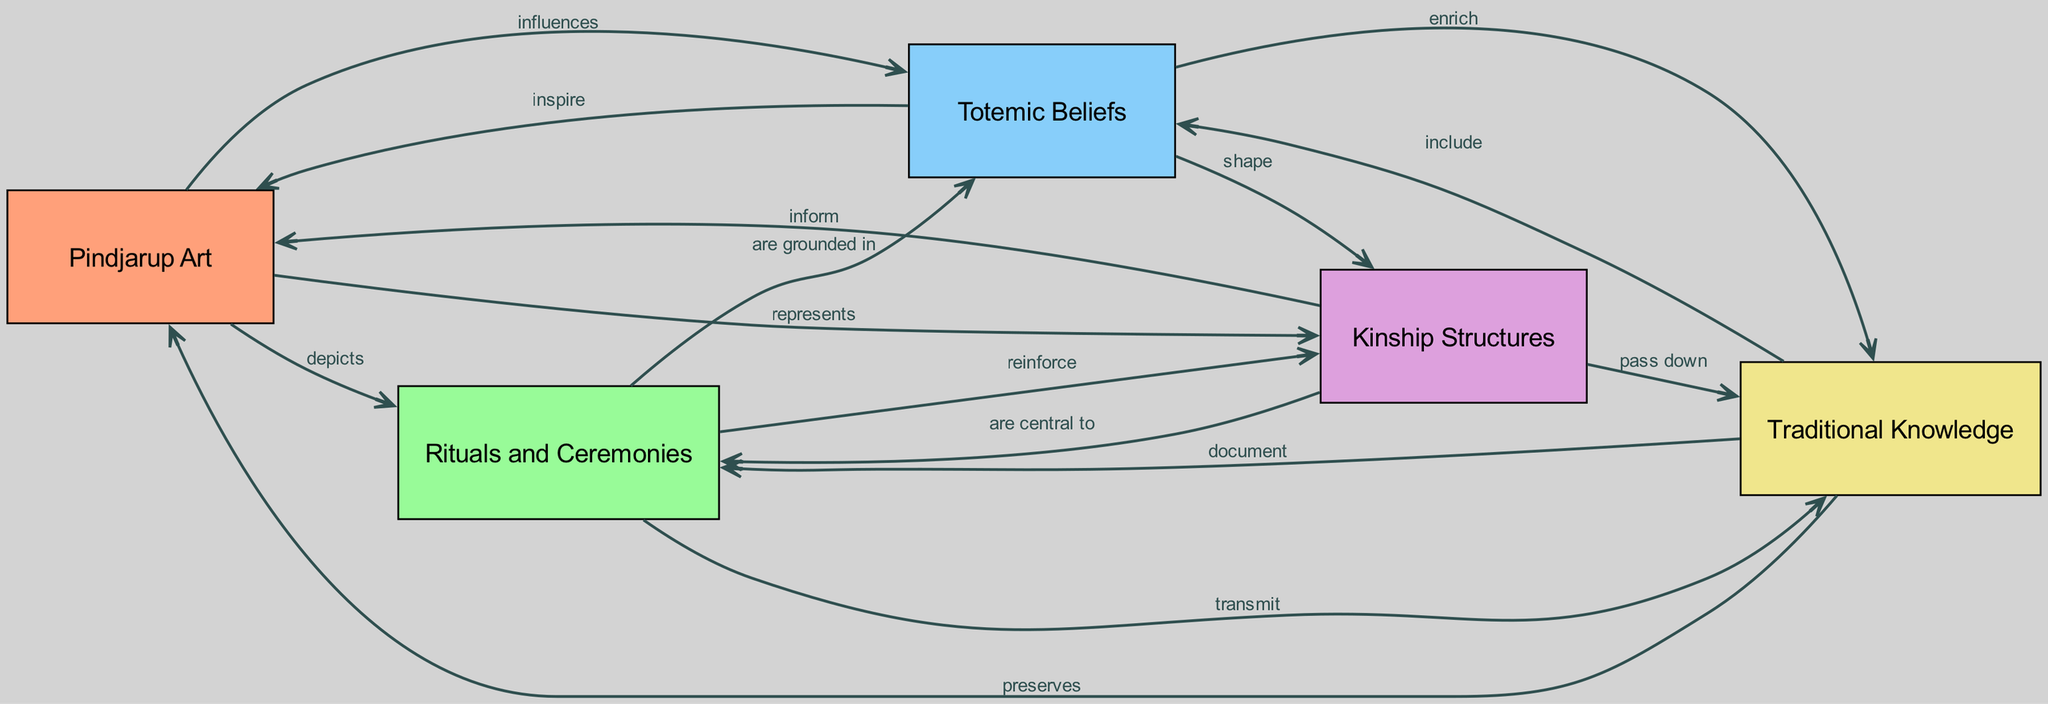What are the three main elements depicted in the diagram? The diagram includes Pindjarup Art, Rituals and Ceremonies, and Totemic Beliefs as the main elements. Each of these is represented as a separate node in the diagram, illustrating the interconnectedness of these cultural practices.
Answer: Pindjarup Art, Rituals and Ceremonies, Totemic Beliefs What type of relationship exists between Totemic Beliefs and Pindjarup Art? The relationship between Totemic Beliefs and Pindjarup Art is described as "inspire." This indicates that Totemic Beliefs creatively influence the expression of Pindjarup Art in the diagram.
Answer: inspire How many relationships does Kinship Structures have? Kinship Structures has three relationships depicted in the diagram, illustrating its connections and influences on other elements such as Traditional Knowledge, Rituals and Ceremonies, and Pindjarup Art.
Answer: 3 How do Rituals and Ceremonies relate to Traditional Knowledge? Rituals and Ceremonies "transmit" Traditional Knowledge according to the diagram. This indicates that these cultural practices are a means of sharing and passing down knowledge within the Pindjarup community.
Answer: transmit Which element "preserves" Pindjarup Art according to the diagram? The element that "preserves" Pindjarup Art is Traditional Knowledge. This shows the vital role that knowledge plays in maintaining and sustaining cultural art forms within the community.
Answer: Traditional Knowledge What role do Totemic Beliefs play in shaping Kinship Structures? Totemic Beliefs "shape" Kinship Structures as per the diagram, indicating that the beliefs tied to totems significantly influence the familial and social relationships within the community.
Answer: shape Which component of the diagram is central to Rituals and Ceremonies? Kinship Structures is the component depicted as "central to" Rituals and Ceremonies, suggesting that kinship reinforces and forms the foundation for these cultural practices.
Answer: Kinship Structures How does Pindjarup Art relate to Rituals and Ceremonies? Pindjarup Art "depicts" Rituals and Ceremonies, showing that the art serves as a visual expression and representation of these important cultural events within the Pindjarup community.
Answer: depicts 